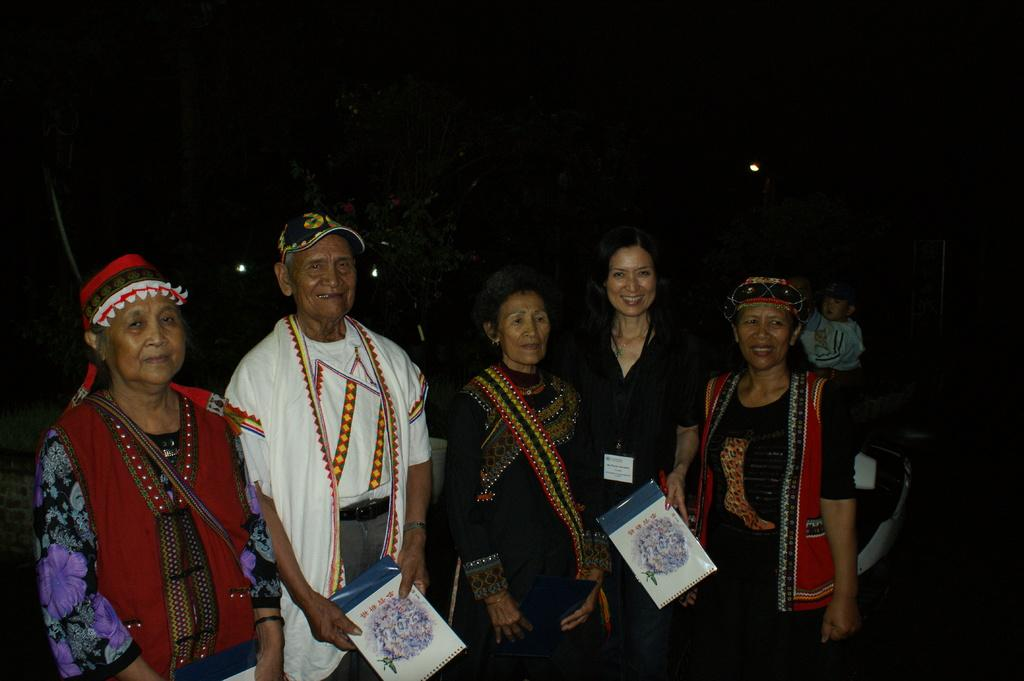What are the people in the image doing? There are people standing in the image. What objects are the people holding? Two people are holding books. How would you describe the lighting in the image? The background of the image is dark, but there are lights visible in the background. What role does the actor play in the image? There is no actor present in the image, as the people in the image are not actors. 